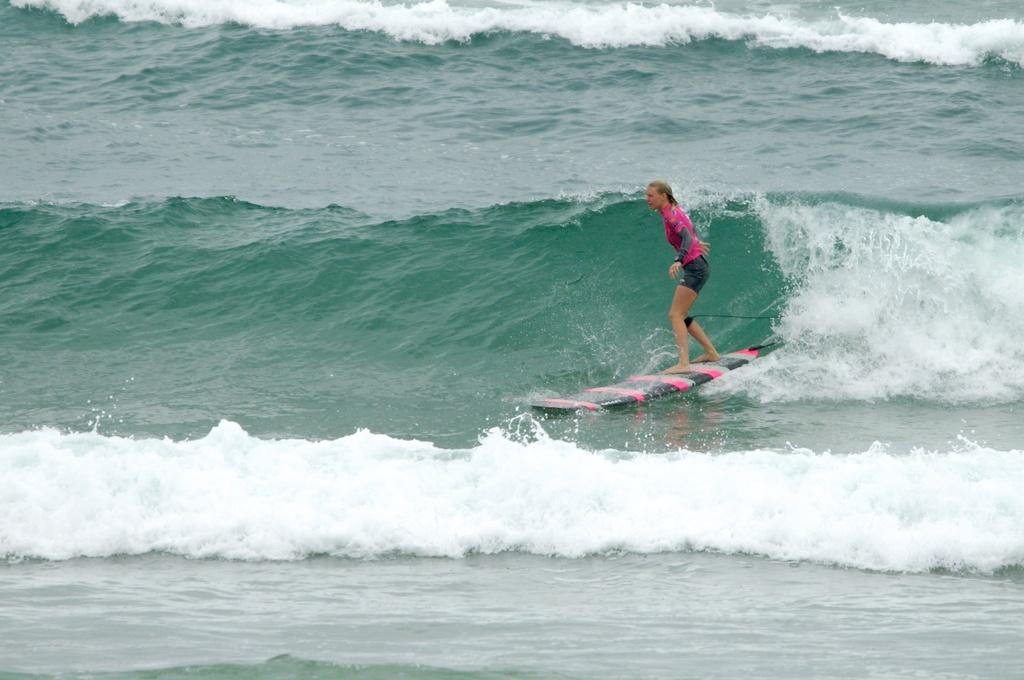What is the main subject of the image? There is a person in the image. What is the person doing in the image? The person is surfing on the water. What can be seen in the background of the image? Water waves are visible in the image. What type of needle is being used by the person in the image? There is no needle present in the image; the person is surfing on the water. What idea does the person have while surfing in the image? The image does not provide any information about the person's thoughts or ideas while surfing. 